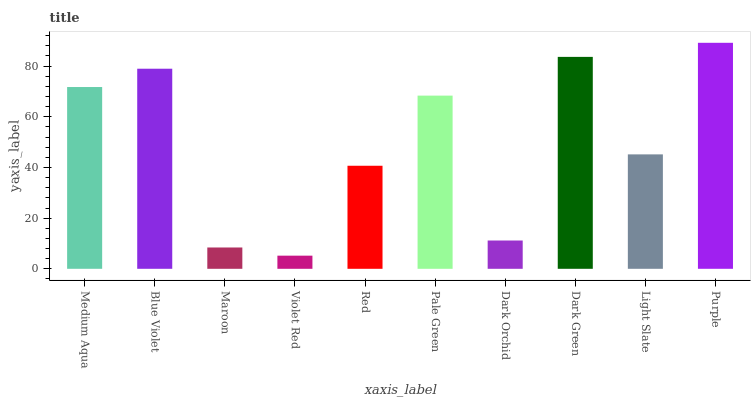Is Violet Red the minimum?
Answer yes or no. Yes. Is Purple the maximum?
Answer yes or no. Yes. Is Blue Violet the minimum?
Answer yes or no. No. Is Blue Violet the maximum?
Answer yes or no. No. Is Blue Violet greater than Medium Aqua?
Answer yes or no. Yes. Is Medium Aqua less than Blue Violet?
Answer yes or no. Yes. Is Medium Aqua greater than Blue Violet?
Answer yes or no. No. Is Blue Violet less than Medium Aqua?
Answer yes or no. No. Is Pale Green the high median?
Answer yes or no. Yes. Is Light Slate the low median?
Answer yes or no. Yes. Is Purple the high median?
Answer yes or no. No. Is Blue Violet the low median?
Answer yes or no. No. 